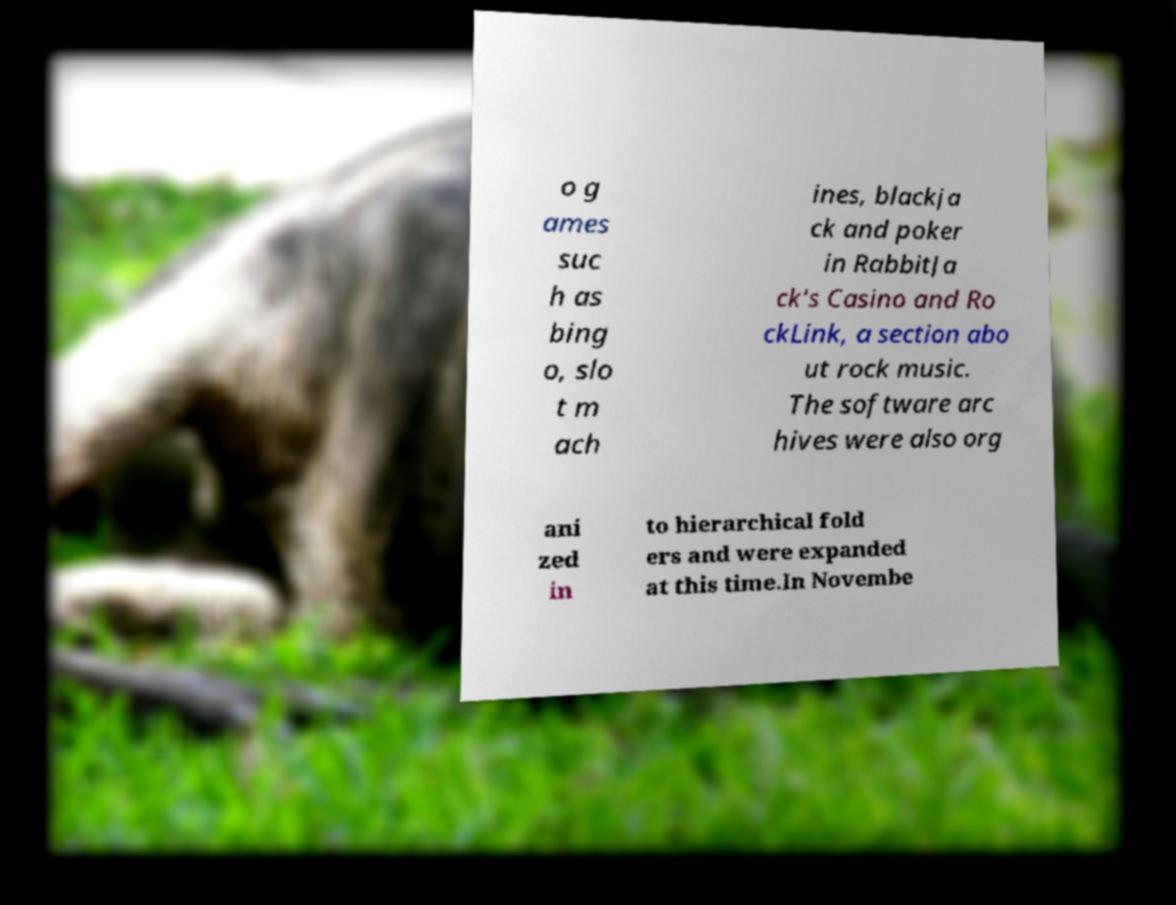I need the written content from this picture converted into text. Can you do that? o g ames suc h as bing o, slo t m ach ines, blackja ck and poker in RabbitJa ck's Casino and Ro ckLink, a section abo ut rock music. The software arc hives were also org ani zed in to hierarchical fold ers and were expanded at this time.In Novembe 